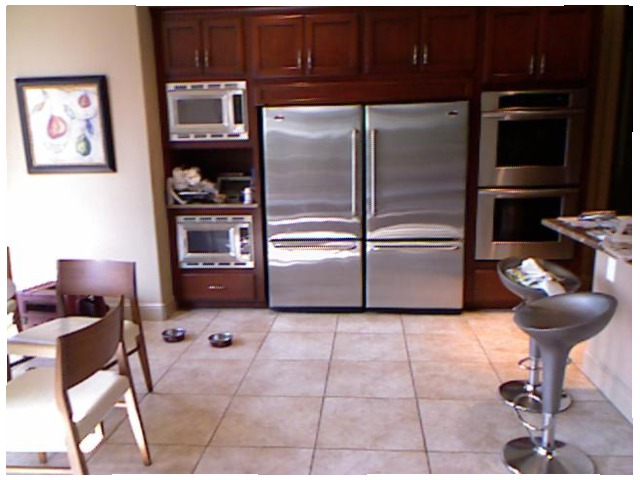<image>
Can you confirm if the fridge is to the left of the cabinet? No. The fridge is not to the left of the cabinet. From this viewpoint, they have a different horizontal relationship. 